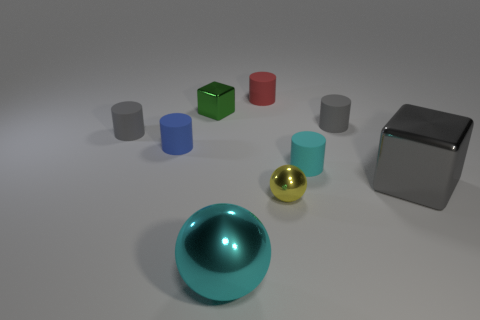What number of other objects are the same color as the big cube?
Ensure brevity in your answer.  2. There is a small gray object that is left of the red matte thing behind the tiny blue cylinder; what shape is it?
Provide a short and direct response. Cylinder. There is a cylinder that is both on the left side of the green shiny thing and behind the tiny blue cylinder; what size is it?
Make the answer very short. Small. Is there a tiny purple matte thing of the same shape as the cyan metal thing?
Provide a succinct answer. No. Are there any other things that are the same shape as the tiny green metallic thing?
Make the answer very short. Yes. What material is the gray thing in front of the small gray rubber object that is left of the cyan object in front of the cyan matte thing made of?
Your response must be concise. Metal. Is there a red cylinder of the same size as the cyan metal object?
Keep it short and to the point. No. What color is the metal cube in front of the tiny shiny cube that is behind the tiny yellow sphere?
Provide a short and direct response. Gray. How many small cubes are there?
Ensure brevity in your answer.  1. Is the tiny block the same color as the small shiny sphere?
Offer a terse response. No. 